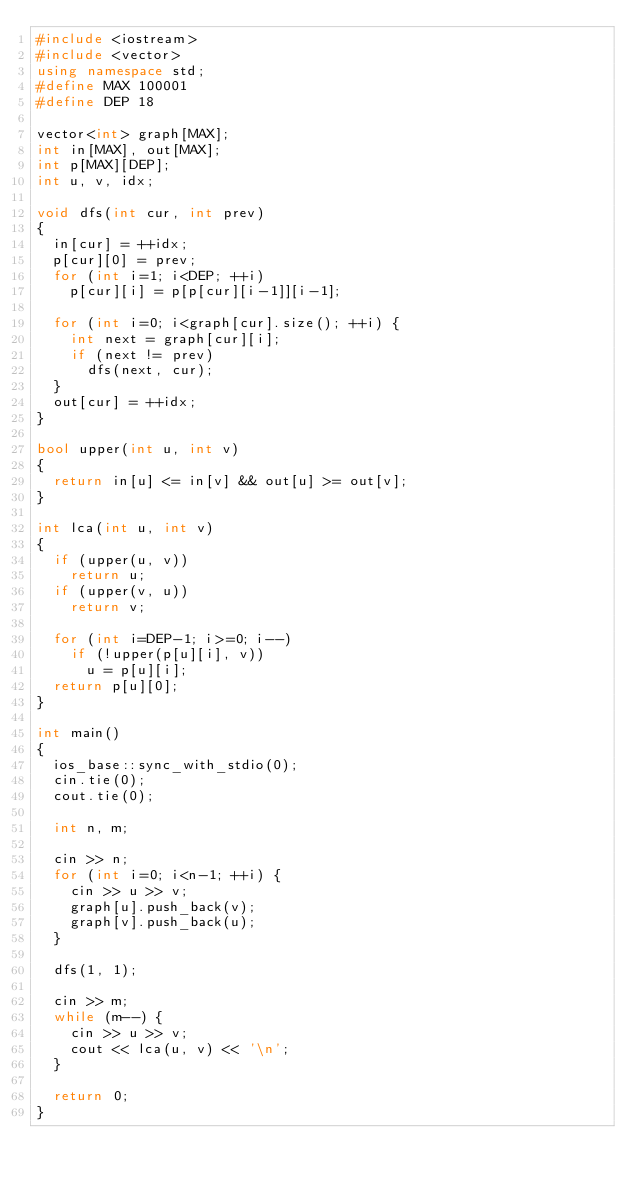<code> <loc_0><loc_0><loc_500><loc_500><_C++_>#include <iostream>
#include <vector>
using namespace std;
#define MAX 100001
#define DEP 18

vector<int> graph[MAX];
int in[MAX], out[MAX];
int p[MAX][DEP];
int u, v, idx;

void dfs(int cur, int prev)
{
	in[cur] = ++idx;
	p[cur][0] = prev;
	for (int i=1; i<DEP; ++i)
		p[cur][i] = p[p[cur][i-1]][i-1];

	for (int i=0; i<graph[cur].size(); ++i) {
		int next = graph[cur][i];
		if (next != prev)
			dfs(next, cur);
	}
	out[cur] = ++idx;
}

bool upper(int u, int v)
{
	return in[u] <= in[v] && out[u] >= out[v];
}

int lca(int u, int v)
{
	if (upper(u, v))
		return u;
	if (upper(v, u))
		return v;

	for (int i=DEP-1; i>=0; i--)
		if (!upper(p[u][i], v))
			u = p[u][i];
	return p[u][0];
}

int main()
{
	ios_base::sync_with_stdio(0);
	cin.tie(0);
	cout.tie(0);

	int n, m;

	cin >> n;
	for (int i=0; i<n-1; ++i) {
		cin >> u >> v;
		graph[u].push_back(v);
		graph[v].push_back(u);
	}

	dfs(1, 1);

	cin >> m;
	while (m--) {
		cin >> u >> v;
		cout << lca(u, v) << '\n';
	}

	return 0;
}
</code> 